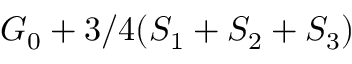Convert formula to latex. <formula><loc_0><loc_0><loc_500><loc_500>G _ { 0 } + 3 / 4 ( S _ { 1 } + S _ { 2 } + S _ { 3 } )</formula> 